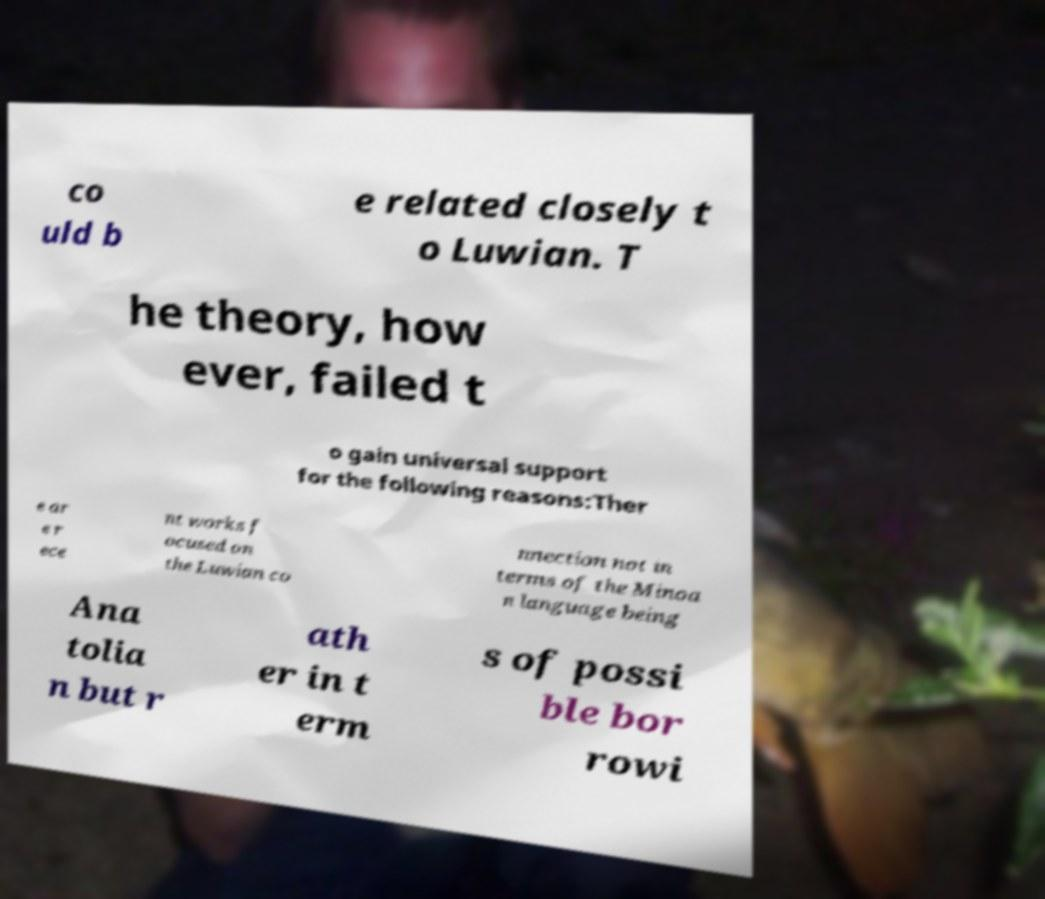Can you read and provide the text displayed in the image?This photo seems to have some interesting text. Can you extract and type it out for me? co uld b e related closely t o Luwian. T he theory, how ever, failed t o gain universal support for the following reasons:Ther e ar e r ece nt works f ocused on the Luwian co nnection not in terms of the Minoa n language being Ana tolia n but r ath er in t erm s of possi ble bor rowi 